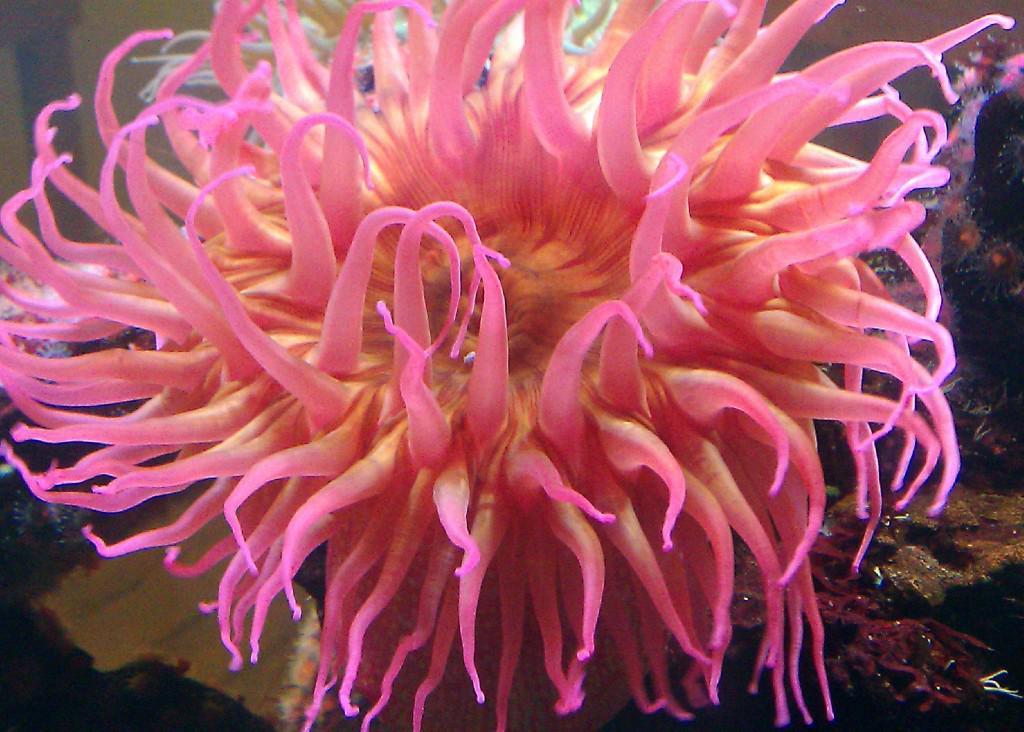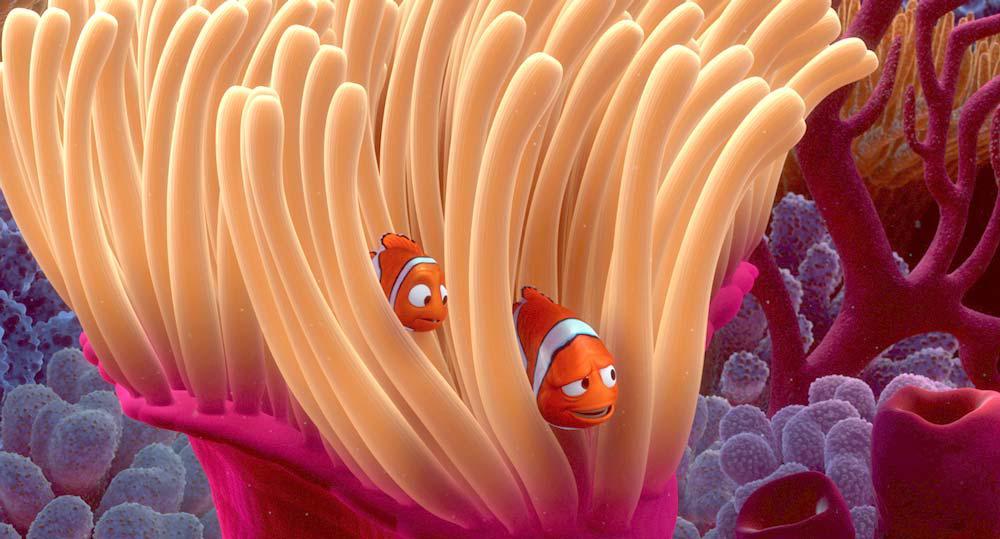The first image is the image on the left, the second image is the image on the right. Examine the images to the left and right. Is the description "Exactly one clownfish swims near the center of an image, amid anemone tendrils." accurate? Answer yes or no. No. 